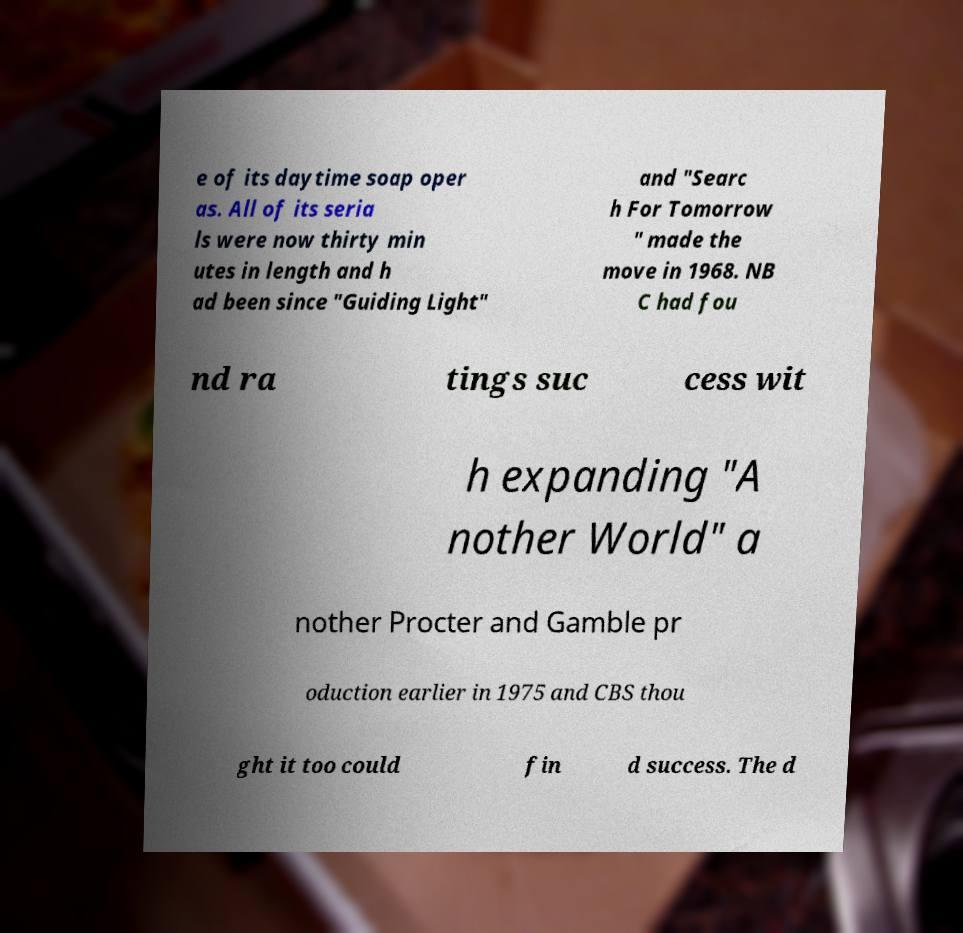There's text embedded in this image that I need extracted. Can you transcribe it verbatim? e of its daytime soap oper as. All of its seria ls were now thirty min utes in length and h ad been since "Guiding Light" and "Searc h For Tomorrow " made the move in 1968. NB C had fou nd ra tings suc cess wit h expanding "A nother World" a nother Procter and Gamble pr oduction earlier in 1975 and CBS thou ght it too could fin d success. The d 